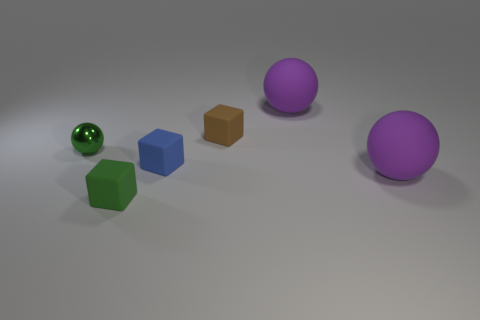What shape is the matte object that is the same color as the tiny metal object?
Your answer should be compact. Cube. What size is the matte thing that is the same color as the shiny sphere?
Offer a very short reply. Small. Is the size of the matte sphere that is in front of the tiny shiny object the same as the green thing that is on the right side of the tiny green metallic object?
Provide a succinct answer. No. What number of balls are either big matte objects or small green rubber things?
Provide a succinct answer. 2. How many shiny objects are tiny green blocks or brown objects?
Your answer should be compact. 0. Is the size of the blue rubber block the same as the purple thing in front of the blue rubber block?
Make the answer very short. No. There is a large object that is behind the blue cube; what shape is it?
Ensure brevity in your answer.  Sphere. What is the color of the rubber object that is right of the big purple ball that is behind the green shiny thing?
Ensure brevity in your answer.  Purple. What number of matte objects have the same color as the small ball?
Your answer should be compact. 1. Do the small ball and the rubber block that is in front of the small blue object have the same color?
Keep it short and to the point. Yes. 